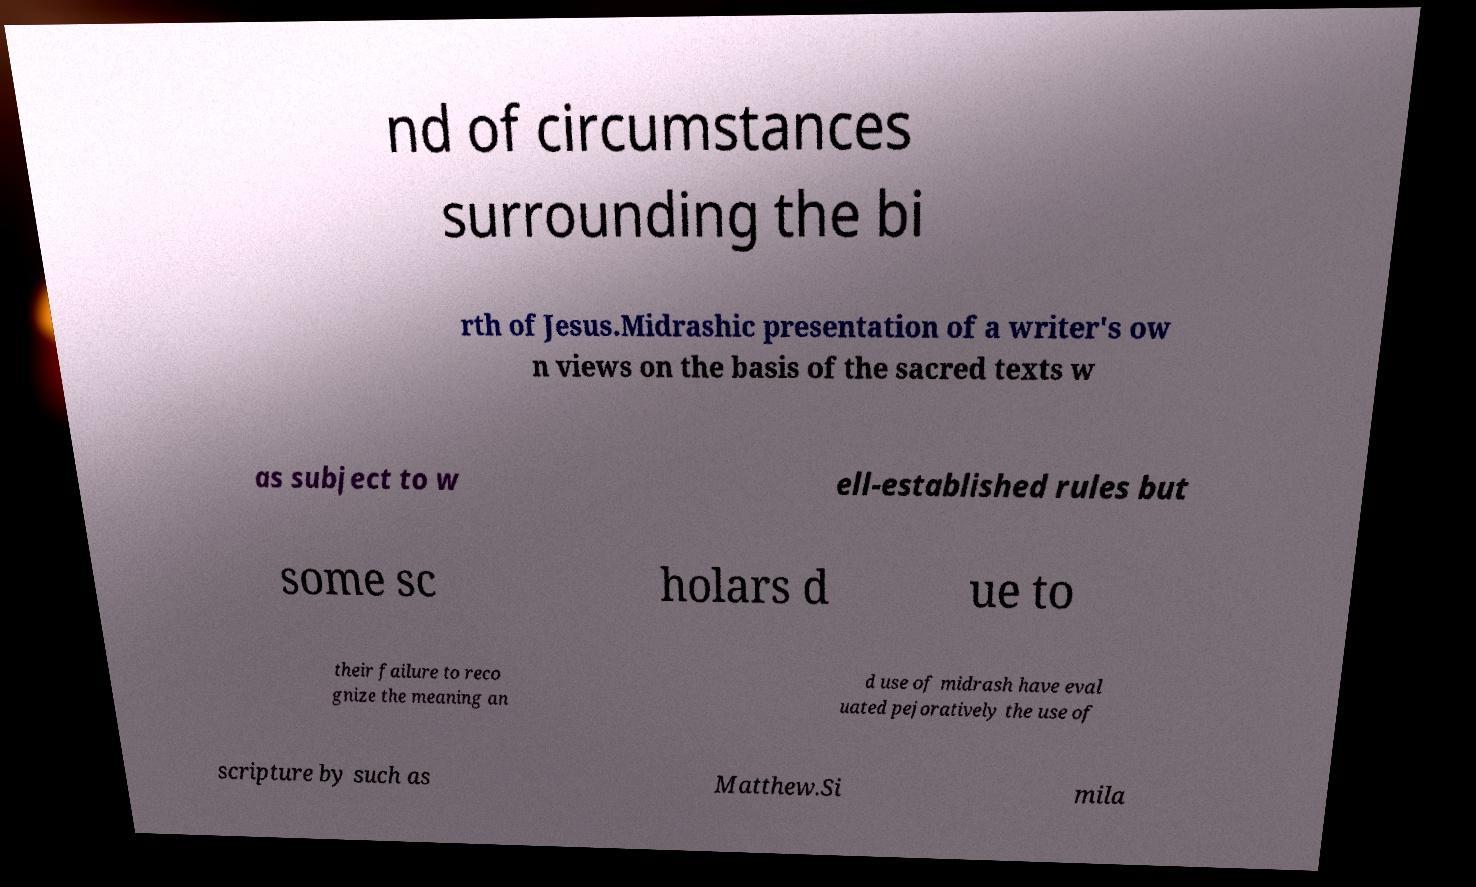What messages or text are displayed in this image? I need them in a readable, typed format. nd of circumstances surrounding the bi rth of Jesus.Midrashic presentation of a writer's ow n views on the basis of the sacred texts w as subject to w ell-established rules but some sc holars d ue to their failure to reco gnize the meaning an d use of midrash have eval uated pejoratively the use of scripture by such as Matthew.Si mila 